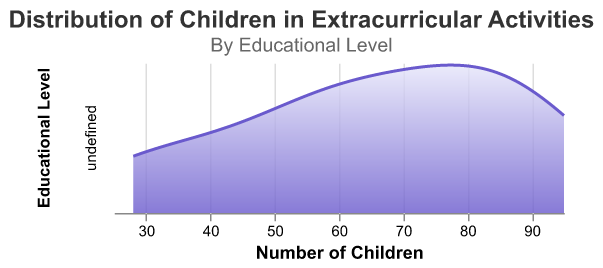How many educational levels are represented? The density subplot features are divided by educational levels, each represented as a separate row in the chart. There are a total of four rows, indicating four educational levels.
Answer: 4 At which educational level do the most children participate in extracurricular activities? The density plot for High School shows the highest number of children, with the highest density peak and a range between 85 and 95 children.
Answer: High School What is the title of the subplot? The title is displayed at the top of the subplot. It reads "Distribution of Children in Extracurricular Activities."
Answer: Distribution of Children in Extracurricular Activities Which educational level has the widest range of children participating in the activities? By examining the widths of the density plots, the High School level has the widest range, spanning from around 85 to 95 children.
Answer: High School What is the unique color feature for the density lines and areas? The density lines are colored in a consistent gradient from blue to light purple (#6A5ACD to #E6E6FA), creating a visually distinct look for each plot's density area.
Answer: Blue to Light Purple Gradient How does the density of children in extracurricular activities differ between Elementary and Middle School? The Elementary density plot shows a range from 55 to 65 children, while the Middle School plot ranges from 70 to 83. The peak density is higher for Middle School, indicating more participation compared to Elementary.
Answer: Middle School has a higher and wider density range than Elementary Which educational level has the lowest maximum number of children involved in extracurricular activities? The Kindergarten density plot peaks at around 50 children, which is lower than the peak numbers for the other educational levels.
Answer: Kindergarten What do the x-axis titles in each plot represent? The x-axis in each density plot represents the "Number of Children" and is labeled with this description across all educational levels.
Answer: Number of Children How does the overall trend of children’s participation change from Kindergarten to High School? There is an increasing trend in the number of children participating in extracurricular activities as educational levels progress from Kindergarten to High School. The number density ranges and peak values increase with higher educational levels.
Answer: Increasing trend 